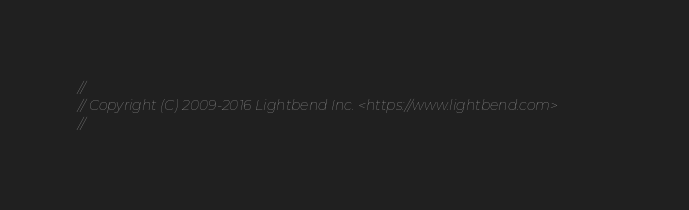<code> <loc_0><loc_0><loc_500><loc_500><_Scala_>//
// Copyright (C) 2009-2016 Lightbend Inc. <https://www.lightbend.com>
//
</code> 